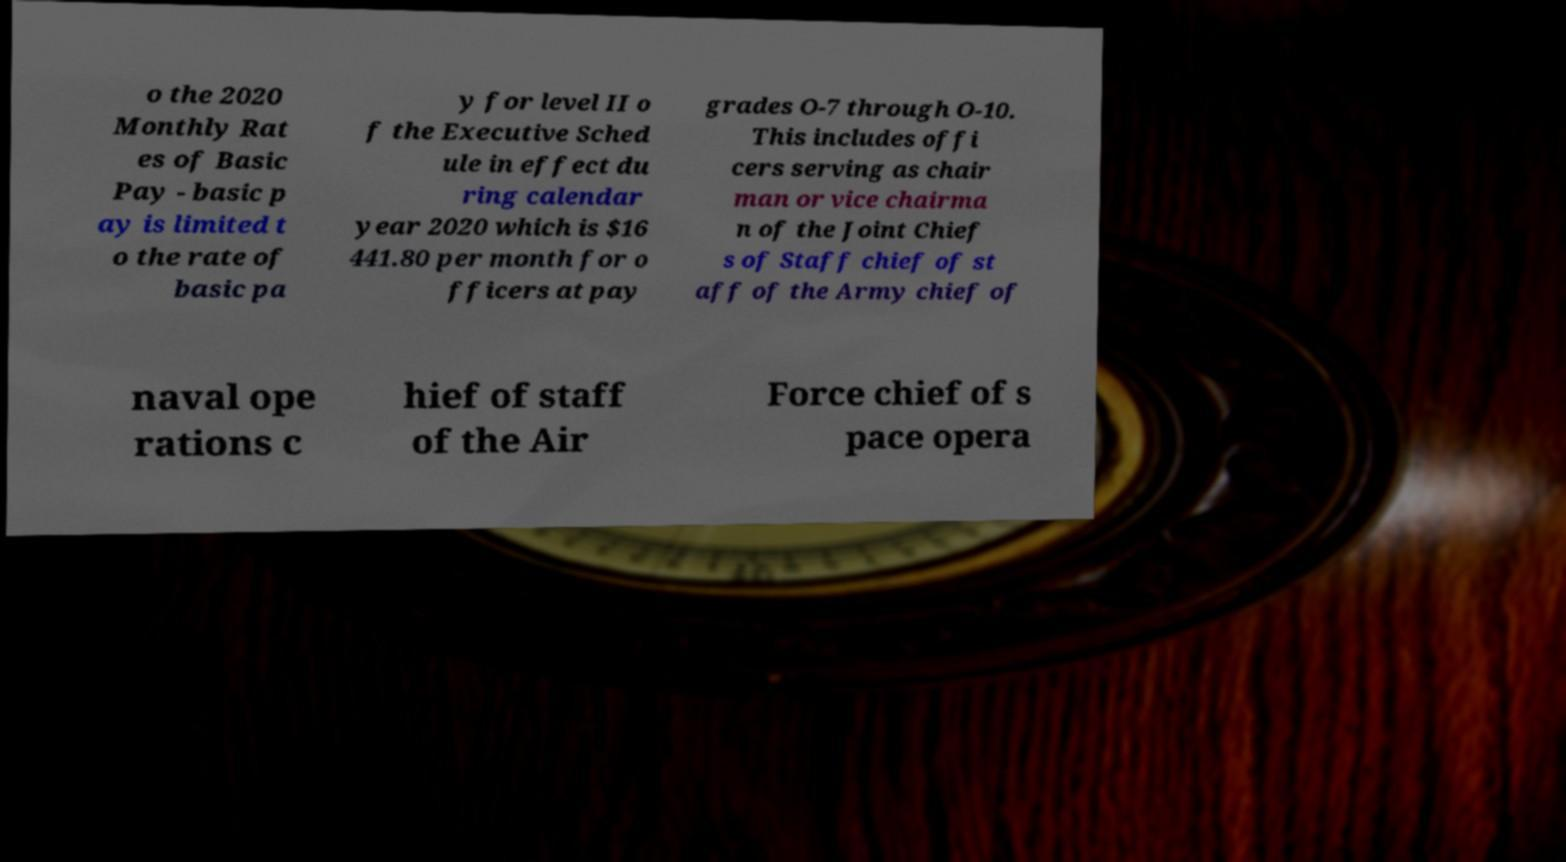There's text embedded in this image that I need extracted. Can you transcribe it verbatim? o the 2020 Monthly Rat es of Basic Pay - basic p ay is limited t o the rate of basic pa y for level II o f the Executive Sched ule in effect du ring calendar year 2020 which is $16 441.80 per month for o fficers at pay grades O-7 through O-10. This includes offi cers serving as chair man or vice chairma n of the Joint Chief s of Staff chief of st aff of the Army chief of naval ope rations c hief of staff of the Air Force chief of s pace opera 